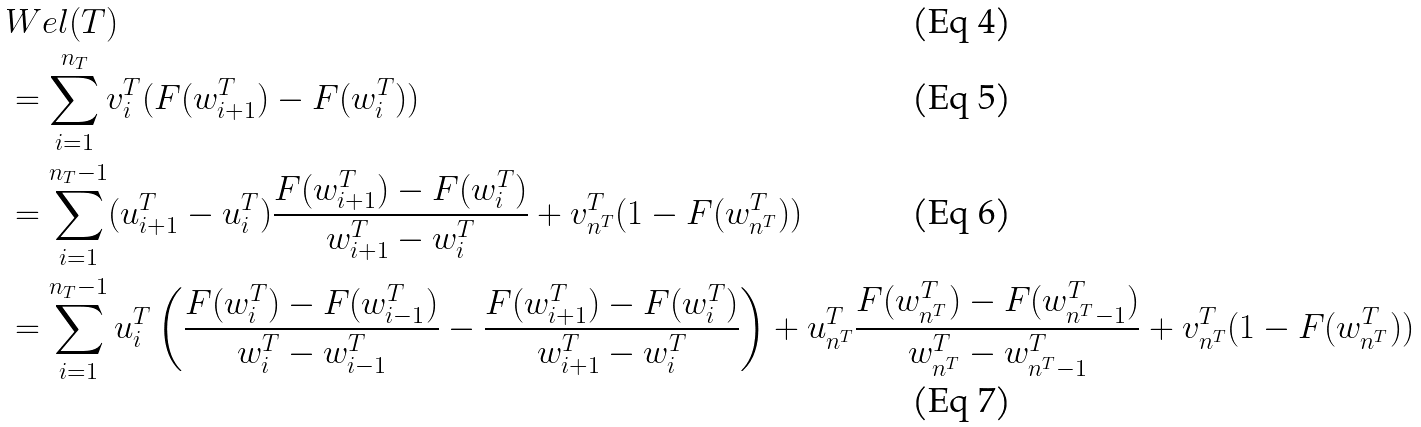Convert formula to latex. <formula><loc_0><loc_0><loc_500><loc_500>& W e l ( T ) \\ & = \sum _ { i = 1 } ^ { n _ { T } } v ^ { T } _ { i } ( F ( w ^ { T } _ { i + 1 } ) - F ( w ^ { T } _ { i } ) ) \\ & = \sum _ { i = 1 } ^ { n _ { T } - 1 } ( u ^ { T } _ { i + 1 } - u ^ { T } _ { i } ) \frac { F ( w ^ { T } _ { i + 1 } ) - F ( w ^ { T } _ { i } ) } { w ^ { T } _ { i + 1 } - w ^ { T } _ { i } } + v ^ { T } _ { n ^ { T } } ( 1 - F ( w ^ { T } _ { n ^ { T } } ) ) \\ & = \sum _ { i = 1 } ^ { n _ { T } - 1 } u ^ { T } _ { i } \left ( \frac { F ( w ^ { T } _ { i } ) - F ( w ^ { T } _ { i - 1 } ) } { w ^ { T } _ { i } - w ^ { T } _ { i - 1 } } - \frac { F ( w ^ { T } _ { i + 1 } ) - F ( w ^ { T } _ { i } ) } { w ^ { T } _ { i + 1 } - w ^ { T } _ { i } } \right ) + u ^ { T } _ { n ^ { T } } \frac { F ( w ^ { T } _ { n ^ { T } } ) - F ( w ^ { T } _ { n ^ { T } - 1 } ) } { w ^ { T } _ { n ^ { T } } - w ^ { T } _ { n ^ { T } - 1 } } + v ^ { T } _ { n ^ { T } } ( 1 - F ( w ^ { T } _ { n ^ { T } } ) )</formula> 